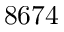<formula> <loc_0><loc_0><loc_500><loc_500>8 6 7 4</formula> 